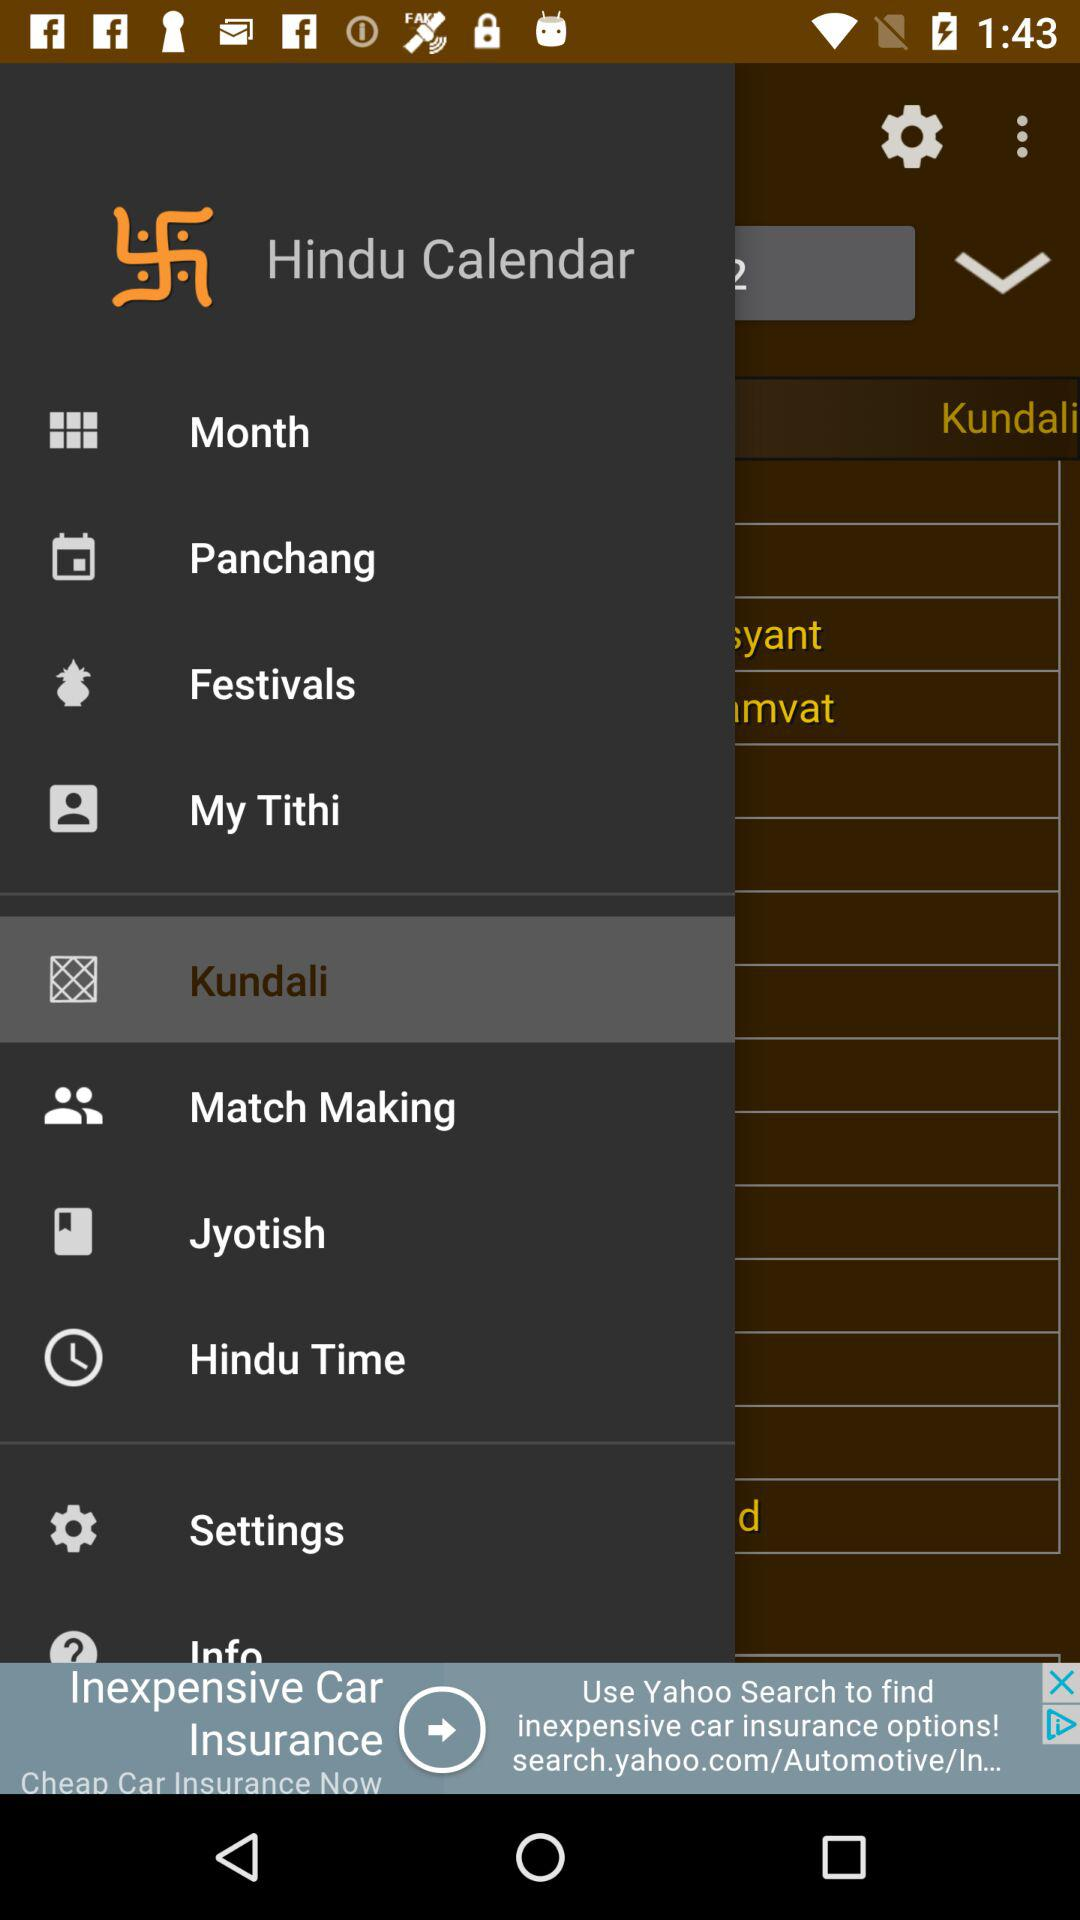What is the application name? The application name is "Hindu Calendar". 